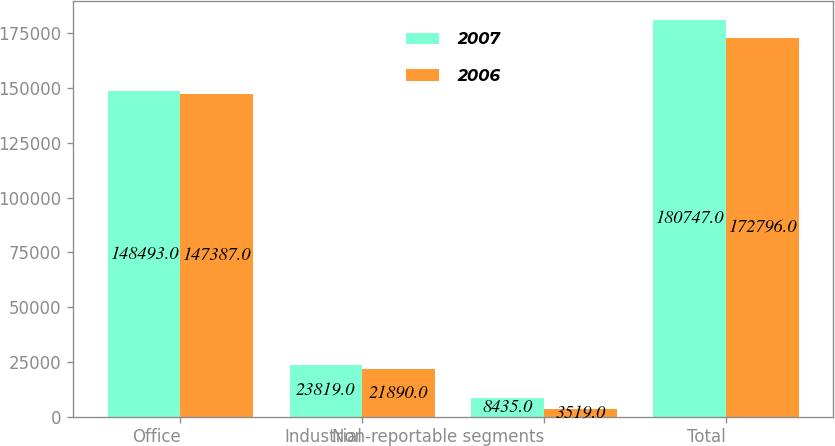<chart> <loc_0><loc_0><loc_500><loc_500><stacked_bar_chart><ecel><fcel>Office<fcel>Industrial<fcel>Non-reportable segments<fcel>Total<nl><fcel>2007<fcel>148493<fcel>23819<fcel>8435<fcel>180747<nl><fcel>2006<fcel>147387<fcel>21890<fcel>3519<fcel>172796<nl></chart> 